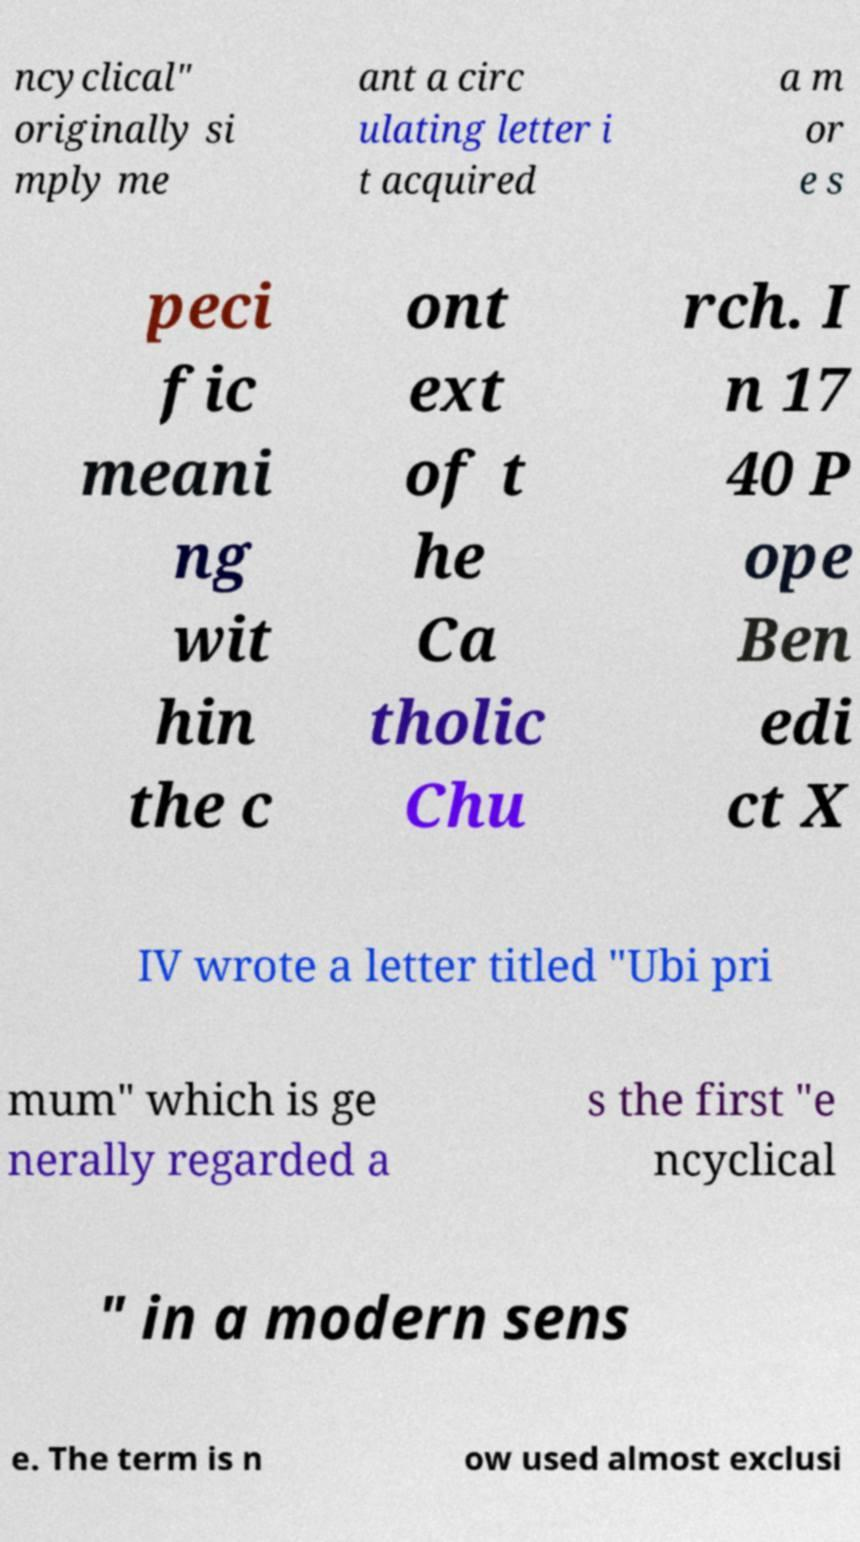Please identify and transcribe the text found in this image. ncyclical" originally si mply me ant a circ ulating letter i t acquired a m or e s peci fic meani ng wit hin the c ont ext of t he Ca tholic Chu rch. I n 17 40 P ope Ben edi ct X IV wrote a letter titled "Ubi pri mum" which is ge nerally regarded a s the first "e ncyclical " in a modern sens e. The term is n ow used almost exclusi 